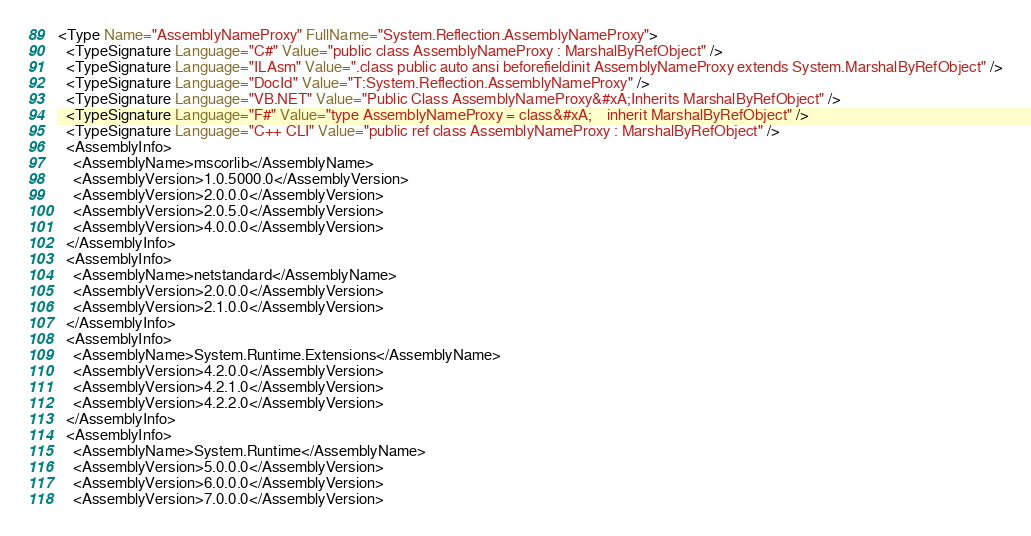<code> <loc_0><loc_0><loc_500><loc_500><_XML_><Type Name="AssemblyNameProxy" FullName="System.Reflection.AssemblyNameProxy">
  <TypeSignature Language="C#" Value="public class AssemblyNameProxy : MarshalByRefObject" />
  <TypeSignature Language="ILAsm" Value=".class public auto ansi beforefieldinit AssemblyNameProxy extends System.MarshalByRefObject" />
  <TypeSignature Language="DocId" Value="T:System.Reflection.AssemblyNameProxy" />
  <TypeSignature Language="VB.NET" Value="Public Class AssemblyNameProxy&#xA;Inherits MarshalByRefObject" />
  <TypeSignature Language="F#" Value="type AssemblyNameProxy = class&#xA;    inherit MarshalByRefObject" />
  <TypeSignature Language="C++ CLI" Value="public ref class AssemblyNameProxy : MarshalByRefObject" />
  <AssemblyInfo>
    <AssemblyName>mscorlib</AssemblyName>
    <AssemblyVersion>1.0.5000.0</AssemblyVersion>
    <AssemblyVersion>2.0.0.0</AssemblyVersion>
    <AssemblyVersion>2.0.5.0</AssemblyVersion>
    <AssemblyVersion>4.0.0.0</AssemblyVersion>
  </AssemblyInfo>
  <AssemblyInfo>
    <AssemblyName>netstandard</AssemblyName>
    <AssemblyVersion>2.0.0.0</AssemblyVersion>
    <AssemblyVersion>2.1.0.0</AssemblyVersion>
  </AssemblyInfo>
  <AssemblyInfo>
    <AssemblyName>System.Runtime.Extensions</AssemblyName>
    <AssemblyVersion>4.2.0.0</AssemblyVersion>
    <AssemblyVersion>4.2.1.0</AssemblyVersion>
    <AssemblyVersion>4.2.2.0</AssemblyVersion>
  </AssemblyInfo>
  <AssemblyInfo>
    <AssemblyName>System.Runtime</AssemblyName>
    <AssemblyVersion>5.0.0.0</AssemblyVersion>
    <AssemblyVersion>6.0.0.0</AssemblyVersion>
    <AssemblyVersion>7.0.0.0</AssemblyVersion></code> 